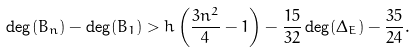Convert formula to latex. <formula><loc_0><loc_0><loc_500><loc_500>\deg ( B _ { n } ) - \deg ( B _ { 1 } ) > h \left ( \frac { 3 n ^ { 2 } } { 4 } - 1 \right ) - \frac { 1 5 } { 3 2 } \deg ( \Delta _ { E } ) - \frac { 3 5 } { 2 4 } .</formula> 